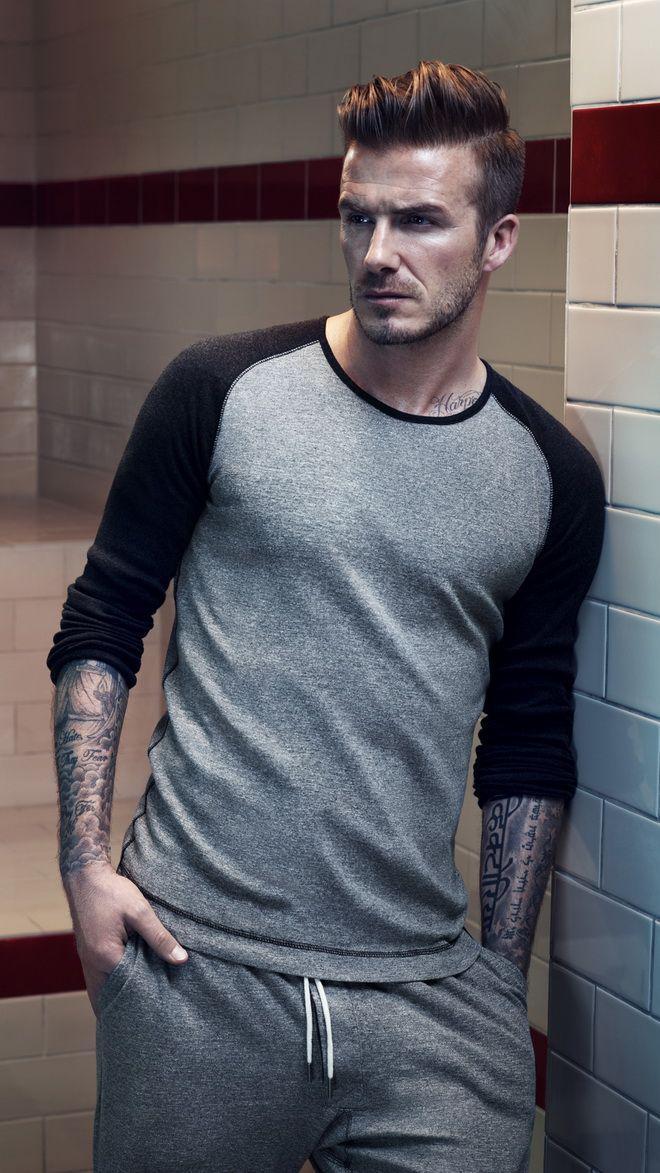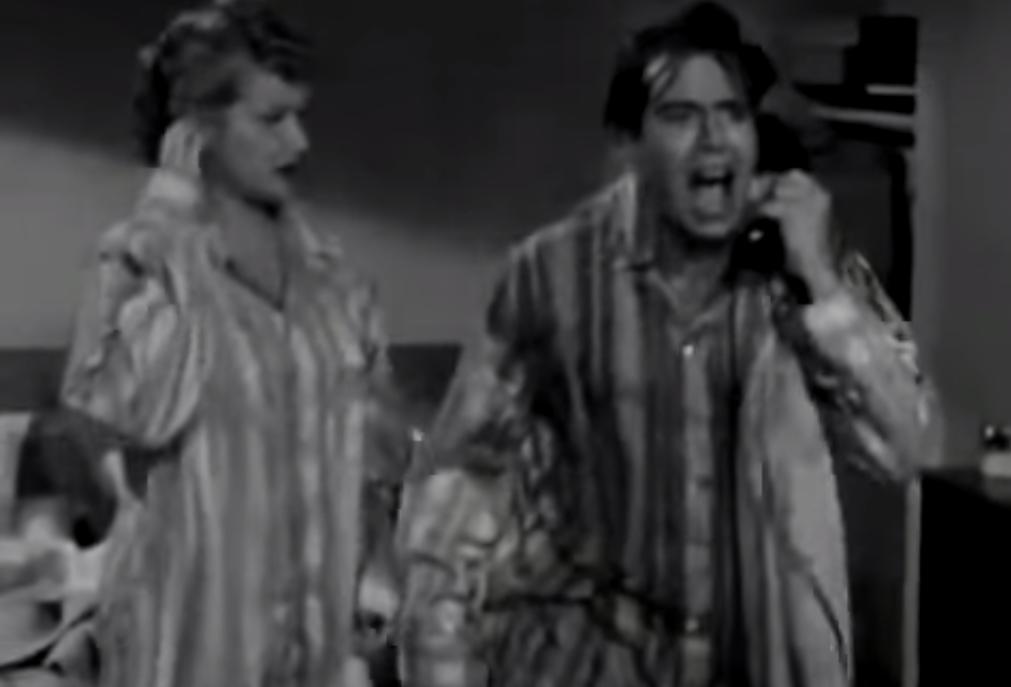The first image is the image on the left, the second image is the image on the right. For the images displayed, is the sentence "An image includes one forward-facing man in sleepwear who is lifting a corded black telephone to his ear, and the other image shows a man standing wearing grey sweatpants." factually correct? Answer yes or no. Yes. The first image is the image on the left, the second image is the image on the right. Examine the images to the left and right. Is the description "the right image shows a man in a seated position wearing blue, long sleeved pajamas" accurate? Answer yes or no. No. 